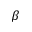<formula> <loc_0><loc_0><loc_500><loc_500>\beta</formula> 